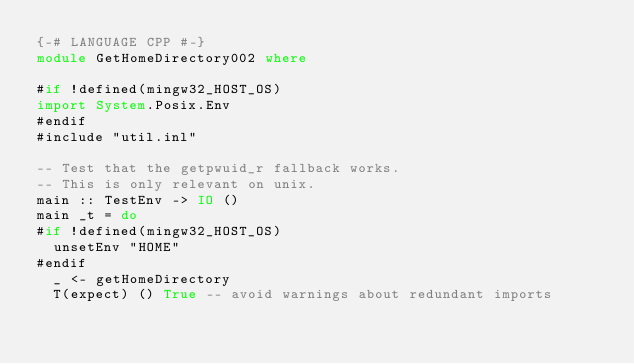<code> <loc_0><loc_0><loc_500><loc_500><_Haskell_>{-# LANGUAGE CPP #-}
module GetHomeDirectory002 where

#if !defined(mingw32_HOST_OS)
import System.Posix.Env
#endif
#include "util.inl"

-- Test that the getpwuid_r fallback works.
-- This is only relevant on unix.
main :: TestEnv -> IO ()
main _t = do
#if !defined(mingw32_HOST_OS)
  unsetEnv "HOME"
#endif
  _ <- getHomeDirectory
  T(expect) () True -- avoid warnings about redundant imports
</code> 